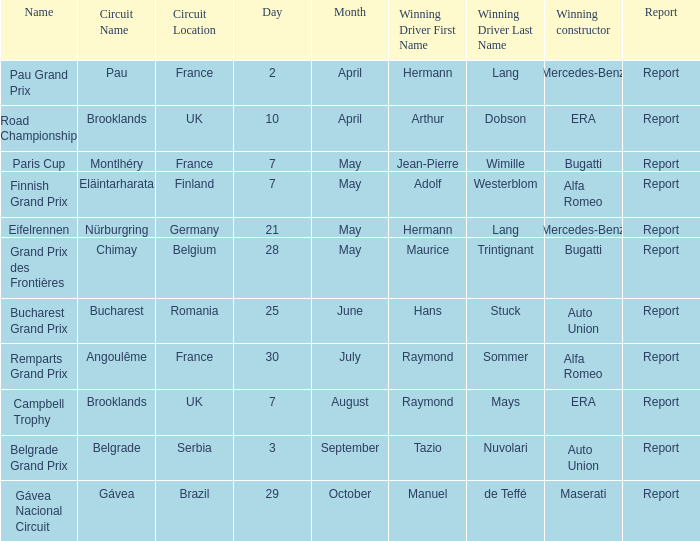Tell me the winning driver for pau grand prix Hermann Lang. 